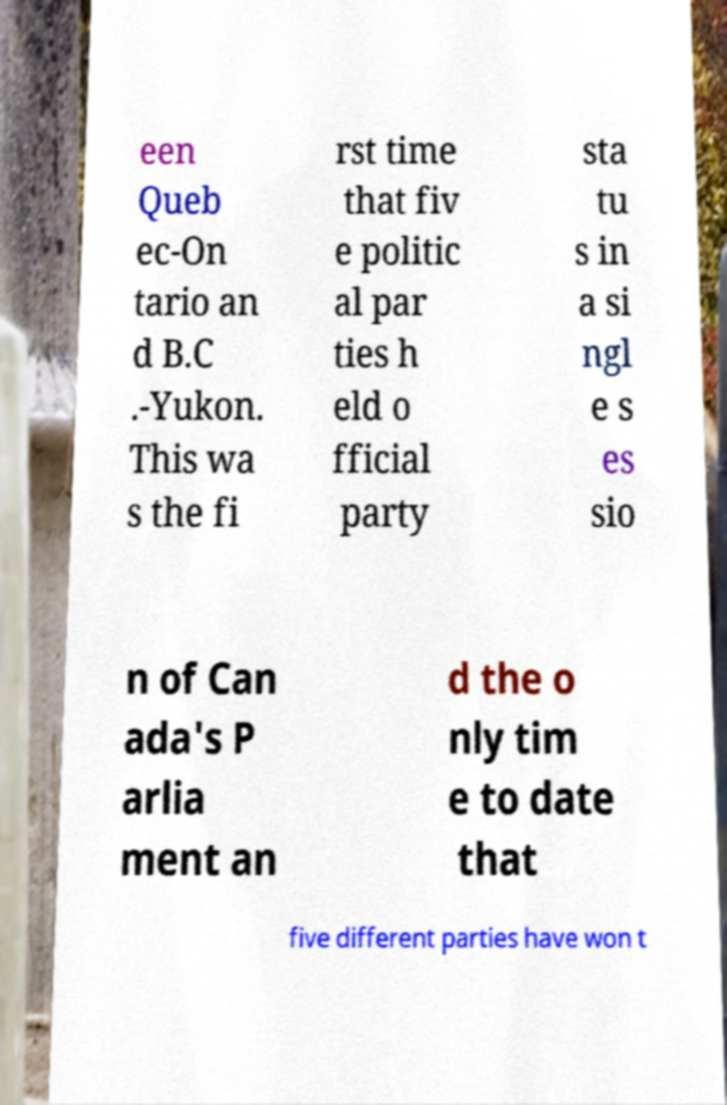What messages or text are displayed in this image? I need them in a readable, typed format. een Queb ec-On tario an d B.C .-Yukon. This wa s the fi rst time that fiv e politic al par ties h eld o fficial party sta tu s in a si ngl e s es sio n of Can ada's P arlia ment an d the o nly tim e to date that five different parties have won t 